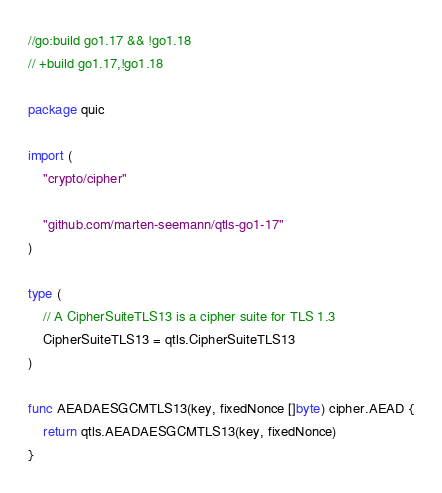<code> <loc_0><loc_0><loc_500><loc_500><_Go_>//go:build go1.17 && !go1.18
// +build go1.17,!go1.18

package quic

import (
	"crypto/cipher"

	"github.com/marten-seemann/qtls-go1-17"
)

type (
	// A CipherSuiteTLS13 is a cipher suite for TLS 1.3
	CipherSuiteTLS13 = qtls.CipherSuiteTLS13
)

func AEADAESGCMTLS13(key, fixedNonce []byte) cipher.AEAD {
	return qtls.AEADAESGCMTLS13(key, fixedNonce)
}
</code> 